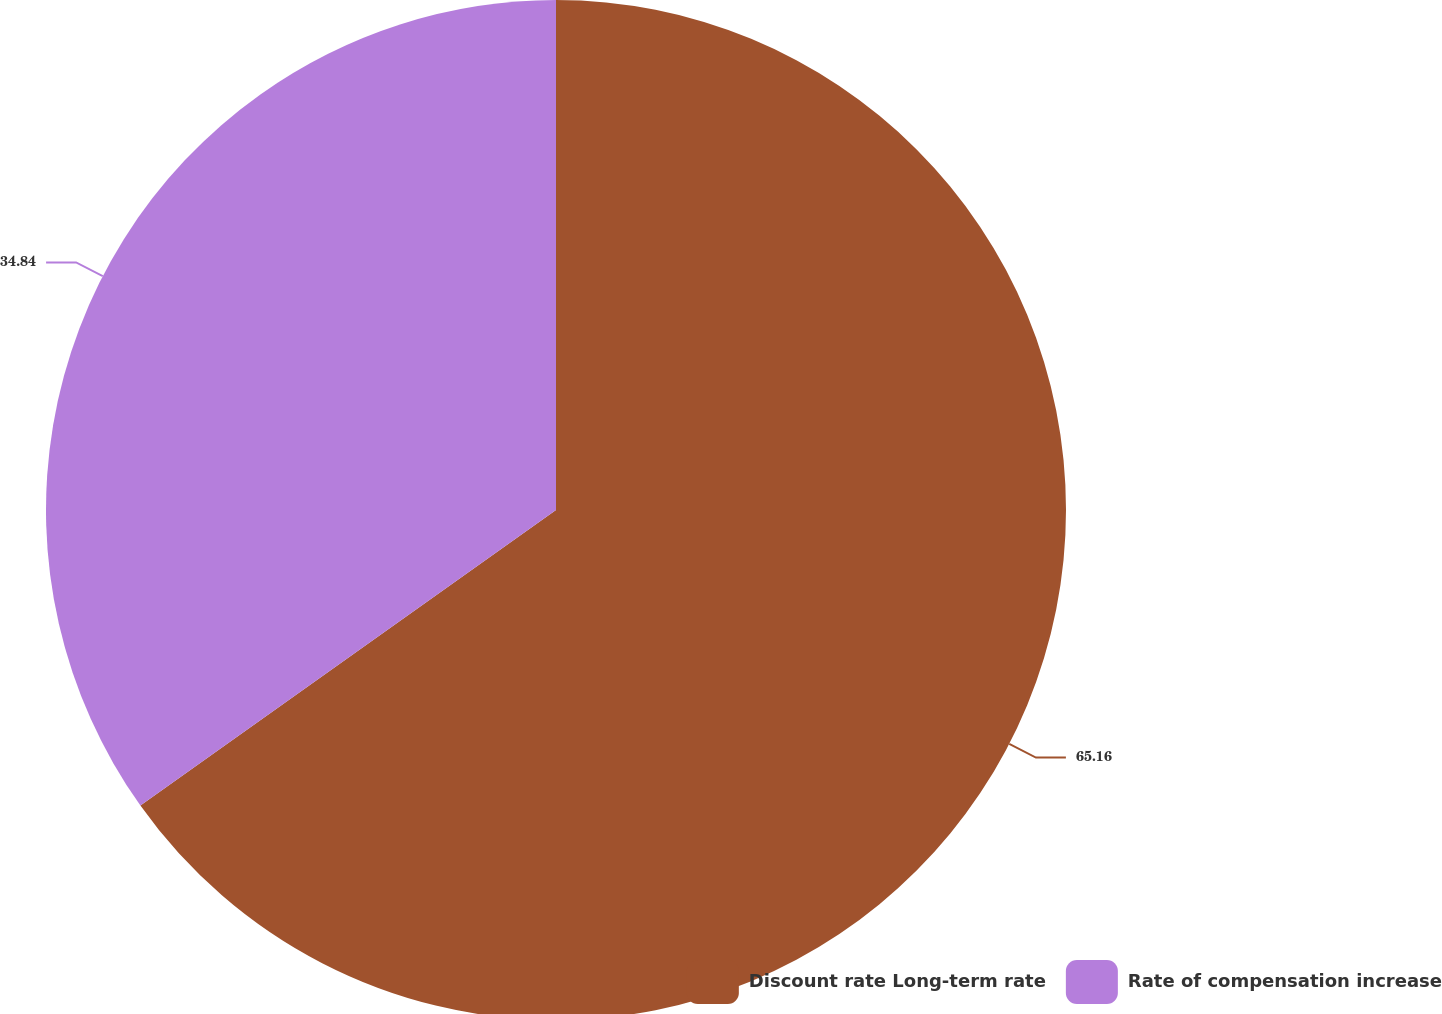Convert chart. <chart><loc_0><loc_0><loc_500><loc_500><pie_chart><fcel>Discount rate Long-term rate<fcel>Rate of compensation increase<nl><fcel>65.16%<fcel>34.84%<nl></chart> 